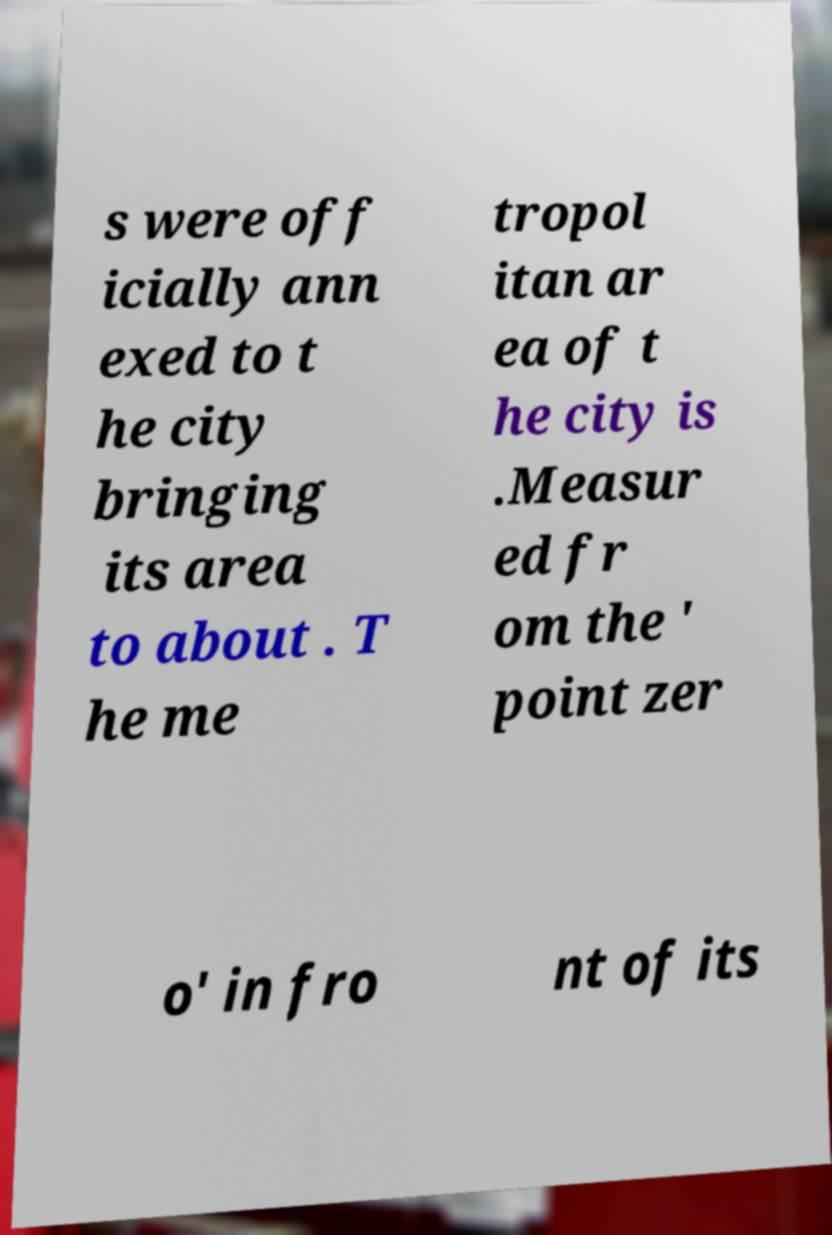Please read and relay the text visible in this image. What does it say? s were off icially ann exed to t he city bringing its area to about . T he me tropol itan ar ea of t he city is .Measur ed fr om the ' point zer o' in fro nt of its 